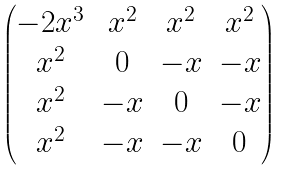<formula> <loc_0><loc_0><loc_500><loc_500>\begin{pmatrix} - 2 x ^ { 3 } & x ^ { 2 } & x ^ { 2 } & x ^ { 2 } \\ x ^ { 2 } & 0 & - x & - x \\ x ^ { 2 } & - x & 0 & - x \\ x ^ { 2 } & - x & - x & 0 \end{pmatrix}</formula> 